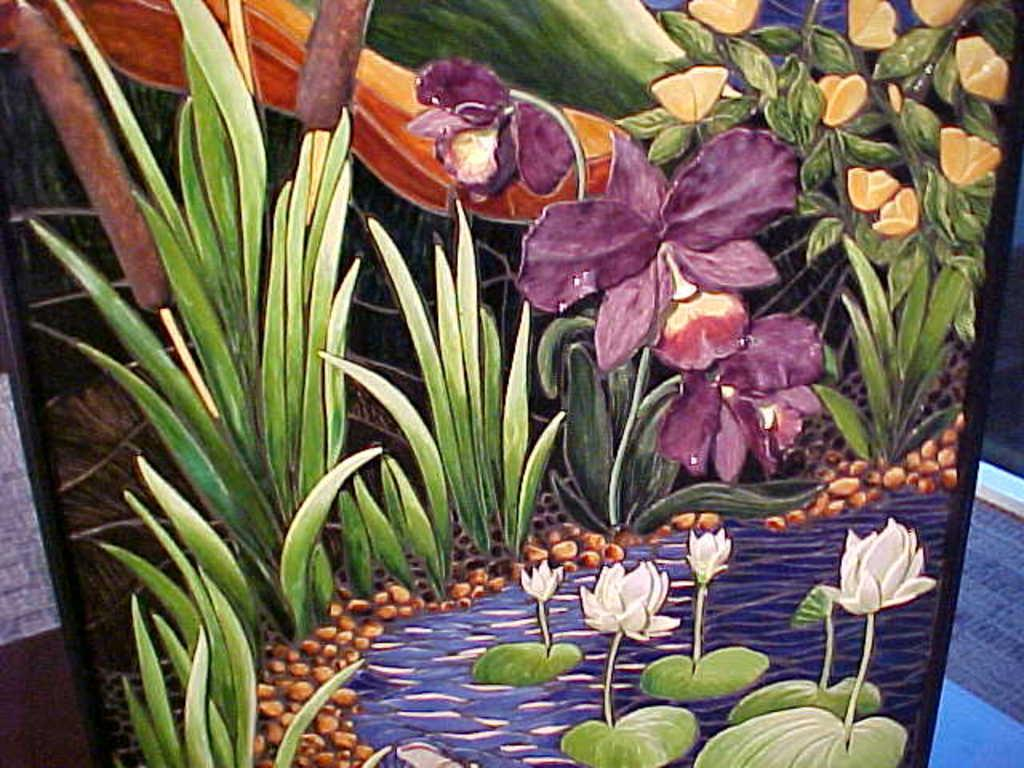What is the main subject of the painting in the image? The painting depicts plants in the image. Can you describe the setting of the painting? The painting depicts plants on water. Are there any other types of plants visible in the image? Yes, there are other floral plants in the image. What type of button can be seen on the plants in the image? There is no button present on the plants in the image; it is a painting of plants on water. 